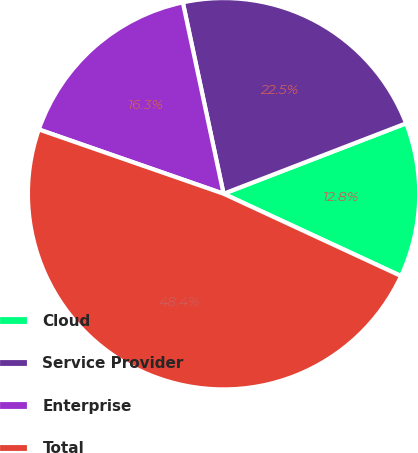Convert chart. <chart><loc_0><loc_0><loc_500><loc_500><pie_chart><fcel>Cloud<fcel>Service Provider<fcel>Enterprise<fcel>Total<nl><fcel>12.77%<fcel>22.48%<fcel>16.33%<fcel>48.42%<nl></chart> 